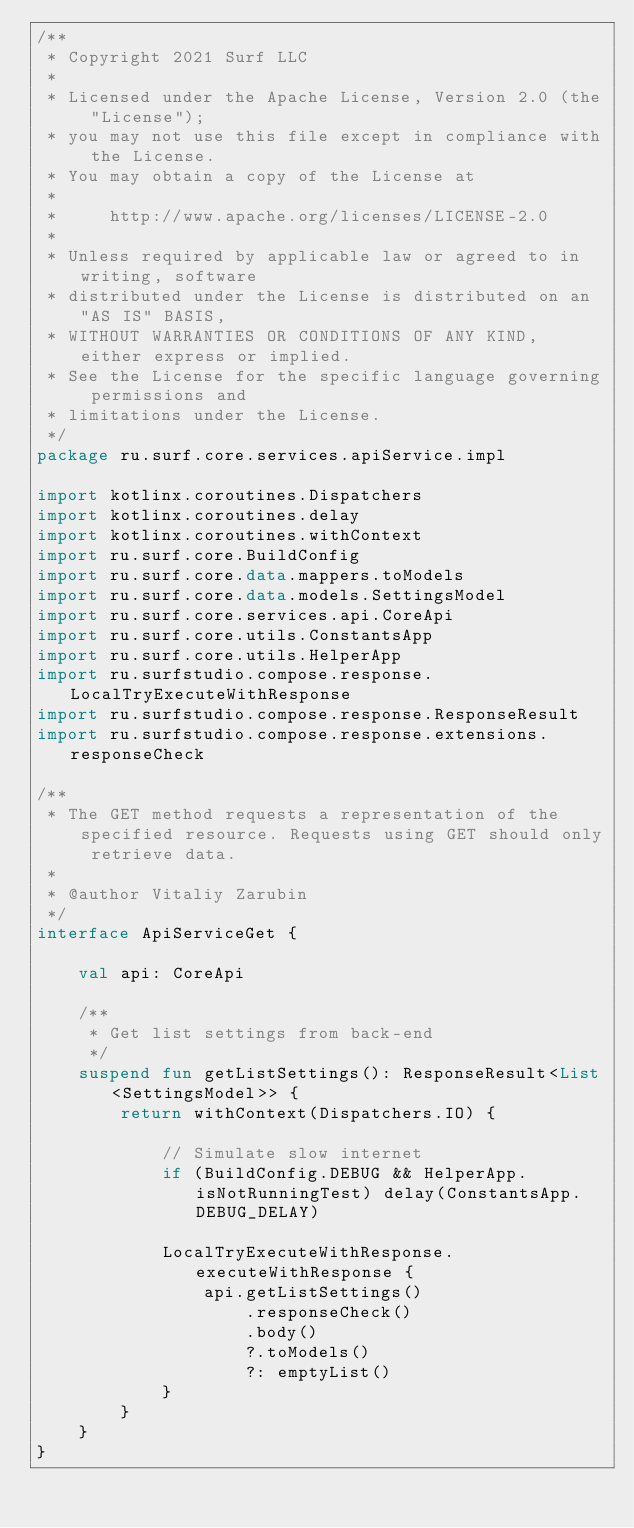<code> <loc_0><loc_0><loc_500><loc_500><_Kotlin_>/**
 * Copyright 2021 Surf LLC
 *
 * Licensed under the Apache License, Version 2.0 (the "License");
 * you may not use this file except in compliance with the License.
 * You may obtain a copy of the License at
 *
 *     http://www.apache.org/licenses/LICENSE-2.0
 *
 * Unless required by applicable law or agreed to in writing, software
 * distributed under the License is distributed on an "AS IS" BASIS,
 * WITHOUT WARRANTIES OR CONDITIONS OF ANY KIND, either express or implied.
 * See the License for the specific language governing permissions and
 * limitations under the License.
 */
package ru.surf.core.services.apiService.impl

import kotlinx.coroutines.Dispatchers
import kotlinx.coroutines.delay
import kotlinx.coroutines.withContext
import ru.surf.core.BuildConfig
import ru.surf.core.data.mappers.toModels
import ru.surf.core.data.models.SettingsModel
import ru.surf.core.services.api.CoreApi
import ru.surf.core.utils.ConstantsApp
import ru.surf.core.utils.HelperApp
import ru.surfstudio.compose.response.LocalTryExecuteWithResponse
import ru.surfstudio.compose.response.ResponseResult
import ru.surfstudio.compose.response.extensions.responseCheck

/**
 * The GET method requests a representation of the specified resource. Requests using GET should only retrieve data.
 *
 * @author Vitaliy Zarubin
 */
interface ApiServiceGet {

    val api: CoreApi

    /**
     * Get list settings from back-end
     */
    suspend fun getListSettings(): ResponseResult<List<SettingsModel>> {
        return withContext(Dispatchers.IO) {

            // Simulate slow internet
            if (BuildConfig.DEBUG && HelperApp.isNotRunningTest) delay(ConstantsApp.DEBUG_DELAY)

            LocalTryExecuteWithResponse.executeWithResponse {
                api.getListSettings()
                    .responseCheck()
                    .body()
                    ?.toModels()
                    ?: emptyList()
            }
        }
    }
}
</code> 